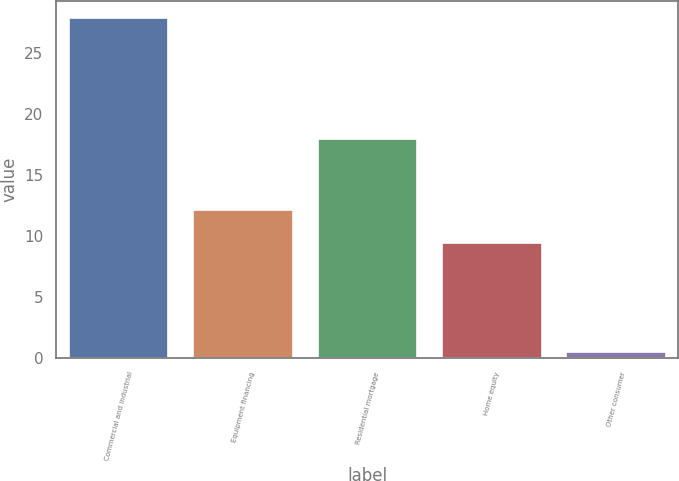Convert chart to OTSL. <chart><loc_0><loc_0><loc_500><loc_500><bar_chart><fcel>Commercial and industrial<fcel>Equipment financing<fcel>Residential mortgage<fcel>Home equity<fcel>Other consumer<nl><fcel>27.8<fcel>12.13<fcel>17.9<fcel>9.4<fcel>0.5<nl></chart> 